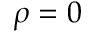<formula> <loc_0><loc_0><loc_500><loc_500>\rho = 0</formula> 